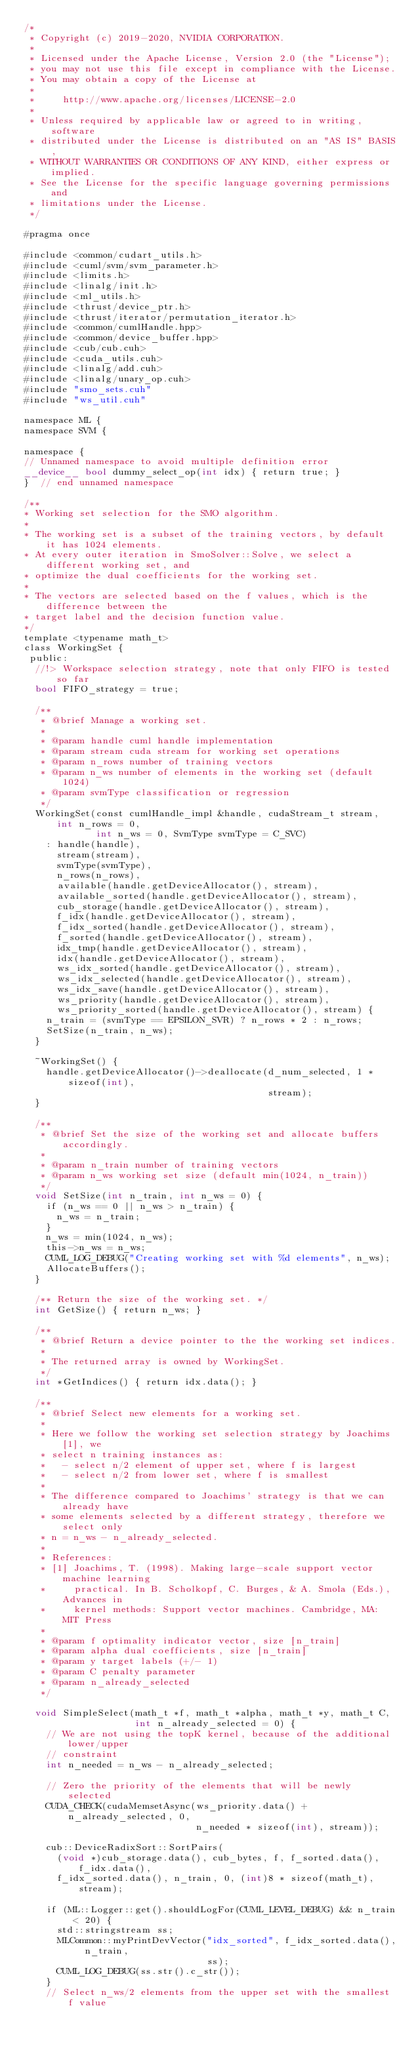Convert code to text. <code><loc_0><loc_0><loc_500><loc_500><_Cuda_>/*
 * Copyright (c) 2019-2020, NVIDIA CORPORATION.
 *
 * Licensed under the Apache License, Version 2.0 (the "License");
 * you may not use this file except in compliance with the License.
 * You may obtain a copy of the License at
 *
 *     http://www.apache.org/licenses/LICENSE-2.0
 *
 * Unless required by applicable law or agreed to in writing, software
 * distributed under the License is distributed on an "AS IS" BASIS,
 * WITHOUT WARRANTIES OR CONDITIONS OF ANY KIND, either express or implied.
 * See the License for the specific language governing permissions and
 * limitations under the License.
 */

#pragma once

#include <common/cudart_utils.h>
#include <cuml/svm/svm_parameter.h>
#include <limits.h>
#include <linalg/init.h>
#include <ml_utils.h>
#include <thrust/device_ptr.h>
#include <thrust/iterator/permutation_iterator.h>
#include <common/cumlHandle.hpp>
#include <common/device_buffer.hpp>
#include <cub/cub.cuh>
#include <cuda_utils.cuh>
#include <linalg/add.cuh>
#include <linalg/unary_op.cuh>
#include "smo_sets.cuh"
#include "ws_util.cuh"

namespace ML {
namespace SVM {

namespace {
// Unnamed namespace to avoid multiple definition error
__device__ bool dummy_select_op(int idx) { return true; }
}  // end unnamed namespace

/**
* Working set selection for the SMO algorithm.
*
* The working set is a subset of the training vectors, by default it has 1024 elements.
* At every outer iteration in SmoSolver::Solve, we select a different working set, and
* optimize the dual coefficients for the working set.
*
* The vectors are selected based on the f values, which is the difference between the
* target label and the decision function value.
*/
template <typename math_t>
class WorkingSet {
 public:
  //!> Workspace selection strategy, note that only FIFO is tested so far
  bool FIFO_strategy = true;

  /**
   * @brief Manage a working set.
   *
   * @param handle cuml handle implementation
   * @param stream cuda stream for working set operations
   * @param n_rows number of training vectors
   * @param n_ws number of elements in the working set (default 1024)
   * @param svmType classification or regression
   */
  WorkingSet(const cumlHandle_impl &handle, cudaStream_t stream, int n_rows = 0,
             int n_ws = 0, SvmType svmType = C_SVC)
    : handle(handle),
      stream(stream),
      svmType(svmType),
      n_rows(n_rows),
      available(handle.getDeviceAllocator(), stream),
      available_sorted(handle.getDeviceAllocator(), stream),
      cub_storage(handle.getDeviceAllocator(), stream),
      f_idx(handle.getDeviceAllocator(), stream),
      f_idx_sorted(handle.getDeviceAllocator(), stream),
      f_sorted(handle.getDeviceAllocator(), stream),
      idx_tmp(handle.getDeviceAllocator(), stream),
      idx(handle.getDeviceAllocator(), stream),
      ws_idx_sorted(handle.getDeviceAllocator(), stream),
      ws_idx_selected(handle.getDeviceAllocator(), stream),
      ws_idx_save(handle.getDeviceAllocator(), stream),
      ws_priority(handle.getDeviceAllocator(), stream),
      ws_priority_sorted(handle.getDeviceAllocator(), stream) {
    n_train = (svmType == EPSILON_SVR) ? n_rows * 2 : n_rows;
    SetSize(n_train, n_ws);
  }

  ~WorkingSet() {
    handle.getDeviceAllocator()->deallocate(d_num_selected, 1 * sizeof(int),
                                            stream);
  }

  /**
   * @brief Set the size of the working set and allocate buffers accordingly.
   *
   * @param n_train number of training vectors
   * @param n_ws working set size (default min(1024, n_train))
   */
  void SetSize(int n_train, int n_ws = 0) {
    if (n_ws == 0 || n_ws > n_train) {
      n_ws = n_train;
    }
    n_ws = min(1024, n_ws);
    this->n_ws = n_ws;
    CUML_LOG_DEBUG("Creating working set with %d elements", n_ws);
    AllocateBuffers();
  }

  /** Return the size of the working set. */
  int GetSize() { return n_ws; }

  /**
   * @brief Return a device pointer to the the working set indices.
   *
   * The returned array is owned by WorkingSet.
   */
  int *GetIndices() { return idx.data(); }

  /**
   * @brief Select new elements for a working set.
   *
   * Here we follow the working set selection strategy by Joachims [1], we
   * select n training instances as:
   *   - select n/2 element of upper set, where f is largest
   *   - select n/2 from lower set, where f is smallest
   *
   * The difference compared to Joachims' strategy is that we can already have
   * some elements selected by a different strategy, therefore we select only
   * n = n_ws - n_already_selected.
   *
   * References:
   * [1] Joachims, T. (1998). Making large-scale support vector machine learning
   *     practical. In B. Scholkopf, C. Burges, & A. Smola (Eds.), Advances in
   *     kernel methods: Support vector machines. Cambridge, MA: MIT Press
   *
   * @param f optimality indicator vector, size [n_train]
   * @param alpha dual coefficients, size [n_train]
   * @param y target labels (+/- 1)
   * @param C penalty parameter
   * @param n_already_selected
   */

  void SimpleSelect(math_t *f, math_t *alpha, math_t *y, math_t C,
                    int n_already_selected = 0) {
    // We are not using the topK kernel, because of the additional lower/upper
    // constraint
    int n_needed = n_ws - n_already_selected;

    // Zero the priority of the elements that will be newly selected
    CUDA_CHECK(cudaMemsetAsync(ws_priority.data() + n_already_selected, 0,
                               n_needed * sizeof(int), stream));

    cub::DeviceRadixSort::SortPairs(
      (void *)cub_storage.data(), cub_bytes, f, f_sorted.data(), f_idx.data(),
      f_idx_sorted.data(), n_train, 0, (int)8 * sizeof(math_t), stream);

    if (ML::Logger::get().shouldLogFor(CUML_LEVEL_DEBUG) && n_train < 20) {
      std::stringstream ss;
      MLCommon::myPrintDevVector("idx_sorted", f_idx_sorted.data(), n_train,
                                 ss);
      CUML_LOG_DEBUG(ss.str().c_str());
    }
    // Select n_ws/2 elements from the upper set with the smallest f value</code> 